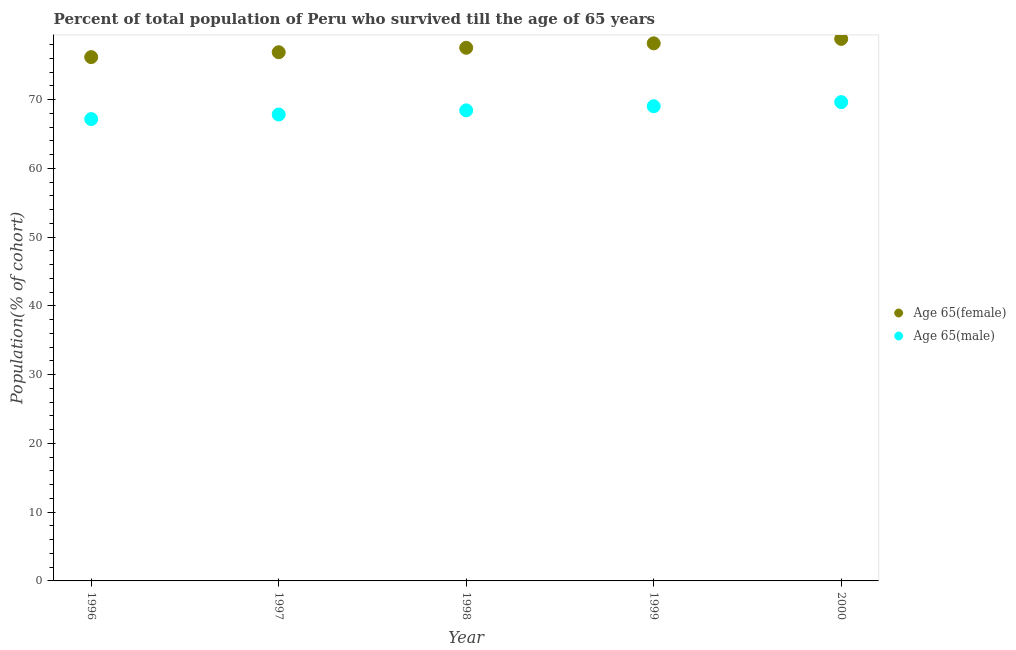How many different coloured dotlines are there?
Offer a very short reply. 2. What is the percentage of male population who survived till age of 65 in 1998?
Your answer should be very brief. 68.43. Across all years, what is the maximum percentage of male population who survived till age of 65?
Ensure brevity in your answer.  69.63. Across all years, what is the minimum percentage of female population who survived till age of 65?
Keep it short and to the point. 76.17. In which year was the percentage of male population who survived till age of 65 maximum?
Offer a very short reply. 2000. What is the total percentage of male population who survived till age of 65 in the graph?
Keep it short and to the point. 342.07. What is the difference between the percentage of male population who survived till age of 65 in 1999 and that in 2000?
Keep it short and to the point. -0.6. What is the difference between the percentage of male population who survived till age of 65 in 2000 and the percentage of female population who survived till age of 65 in 1996?
Your answer should be very brief. -6.55. What is the average percentage of female population who survived till age of 65 per year?
Offer a terse response. 77.52. In the year 1997, what is the difference between the percentage of female population who survived till age of 65 and percentage of male population who survived till age of 65?
Ensure brevity in your answer.  9.06. In how many years, is the percentage of male population who survived till age of 65 greater than 2 %?
Make the answer very short. 5. What is the ratio of the percentage of female population who survived till age of 65 in 1999 to that in 2000?
Give a very brief answer. 0.99. Is the difference between the percentage of female population who survived till age of 65 in 1999 and 2000 greater than the difference between the percentage of male population who survived till age of 65 in 1999 and 2000?
Ensure brevity in your answer.  No. What is the difference between the highest and the second highest percentage of male population who survived till age of 65?
Offer a very short reply. 0.6. What is the difference between the highest and the lowest percentage of male population who survived till age of 65?
Make the answer very short. 2.47. Is the sum of the percentage of female population who survived till age of 65 in 1996 and 1999 greater than the maximum percentage of male population who survived till age of 65 across all years?
Your answer should be compact. Yes. Is the percentage of male population who survived till age of 65 strictly less than the percentage of female population who survived till age of 65 over the years?
Your answer should be very brief. Yes. How many dotlines are there?
Your answer should be compact. 2. How many years are there in the graph?
Offer a very short reply. 5. What is the difference between two consecutive major ticks on the Y-axis?
Keep it short and to the point. 10. Does the graph contain grids?
Provide a short and direct response. No. How many legend labels are there?
Provide a succinct answer. 2. What is the title of the graph?
Your response must be concise. Percent of total population of Peru who survived till the age of 65 years. What is the label or title of the Y-axis?
Keep it short and to the point. Population(% of cohort). What is the Population(% of cohort) of Age 65(female) in 1996?
Your answer should be compact. 76.17. What is the Population(% of cohort) of Age 65(male) in 1996?
Make the answer very short. 67.16. What is the Population(% of cohort) in Age 65(female) in 1997?
Provide a short and direct response. 76.88. What is the Population(% of cohort) in Age 65(male) in 1997?
Offer a terse response. 67.83. What is the Population(% of cohort) of Age 65(female) in 1998?
Provide a succinct answer. 77.53. What is the Population(% of cohort) in Age 65(male) in 1998?
Your answer should be very brief. 68.43. What is the Population(% of cohort) of Age 65(female) in 1999?
Provide a succinct answer. 78.18. What is the Population(% of cohort) of Age 65(male) in 1999?
Your response must be concise. 69.03. What is the Population(% of cohort) in Age 65(female) in 2000?
Your answer should be compact. 78.82. What is the Population(% of cohort) of Age 65(male) in 2000?
Make the answer very short. 69.63. Across all years, what is the maximum Population(% of cohort) in Age 65(female)?
Provide a short and direct response. 78.82. Across all years, what is the maximum Population(% of cohort) of Age 65(male)?
Your answer should be compact. 69.63. Across all years, what is the minimum Population(% of cohort) in Age 65(female)?
Offer a terse response. 76.17. Across all years, what is the minimum Population(% of cohort) in Age 65(male)?
Ensure brevity in your answer.  67.16. What is the total Population(% of cohort) in Age 65(female) in the graph?
Give a very brief answer. 387.59. What is the total Population(% of cohort) of Age 65(male) in the graph?
Provide a short and direct response. 342.07. What is the difference between the Population(% of cohort) of Age 65(female) in 1996 and that in 1997?
Your answer should be compact. -0.71. What is the difference between the Population(% of cohort) of Age 65(male) in 1996 and that in 1997?
Keep it short and to the point. -0.67. What is the difference between the Population(% of cohort) of Age 65(female) in 1996 and that in 1998?
Give a very brief answer. -1.36. What is the difference between the Population(% of cohort) in Age 65(male) in 1996 and that in 1998?
Provide a short and direct response. -1.27. What is the difference between the Population(% of cohort) of Age 65(female) in 1996 and that in 1999?
Ensure brevity in your answer.  -2. What is the difference between the Population(% of cohort) of Age 65(male) in 1996 and that in 1999?
Provide a succinct answer. -1.87. What is the difference between the Population(% of cohort) in Age 65(female) in 1996 and that in 2000?
Offer a very short reply. -2.65. What is the difference between the Population(% of cohort) in Age 65(male) in 1996 and that in 2000?
Provide a succinct answer. -2.47. What is the difference between the Population(% of cohort) in Age 65(female) in 1997 and that in 1998?
Offer a terse response. -0.65. What is the difference between the Population(% of cohort) in Age 65(male) in 1997 and that in 1998?
Give a very brief answer. -0.6. What is the difference between the Population(% of cohort) of Age 65(female) in 1997 and that in 1999?
Provide a succinct answer. -1.29. What is the difference between the Population(% of cohort) in Age 65(male) in 1997 and that in 1999?
Your answer should be very brief. -1.2. What is the difference between the Population(% of cohort) in Age 65(female) in 1997 and that in 2000?
Give a very brief answer. -1.94. What is the difference between the Population(% of cohort) in Age 65(male) in 1997 and that in 2000?
Your answer should be very brief. -1.8. What is the difference between the Population(% of cohort) of Age 65(female) in 1998 and that in 1999?
Your response must be concise. -0.65. What is the difference between the Population(% of cohort) of Age 65(male) in 1998 and that in 1999?
Offer a very short reply. -0.6. What is the difference between the Population(% of cohort) in Age 65(female) in 1998 and that in 2000?
Your answer should be very brief. -1.29. What is the difference between the Population(% of cohort) of Age 65(male) in 1998 and that in 2000?
Offer a terse response. -1.2. What is the difference between the Population(% of cohort) in Age 65(female) in 1999 and that in 2000?
Provide a succinct answer. -0.65. What is the difference between the Population(% of cohort) of Age 65(male) in 1999 and that in 2000?
Keep it short and to the point. -0.6. What is the difference between the Population(% of cohort) of Age 65(female) in 1996 and the Population(% of cohort) of Age 65(male) in 1997?
Your answer should be very brief. 8.35. What is the difference between the Population(% of cohort) of Age 65(female) in 1996 and the Population(% of cohort) of Age 65(male) in 1998?
Your answer should be compact. 7.75. What is the difference between the Population(% of cohort) of Age 65(female) in 1996 and the Population(% of cohort) of Age 65(male) in 1999?
Make the answer very short. 7.15. What is the difference between the Population(% of cohort) in Age 65(female) in 1996 and the Population(% of cohort) in Age 65(male) in 2000?
Ensure brevity in your answer.  6.55. What is the difference between the Population(% of cohort) of Age 65(female) in 1997 and the Population(% of cohort) of Age 65(male) in 1998?
Make the answer very short. 8.46. What is the difference between the Population(% of cohort) of Age 65(female) in 1997 and the Population(% of cohort) of Age 65(male) in 1999?
Your response must be concise. 7.86. What is the difference between the Population(% of cohort) in Age 65(female) in 1997 and the Population(% of cohort) in Age 65(male) in 2000?
Keep it short and to the point. 7.26. What is the difference between the Population(% of cohort) of Age 65(female) in 1998 and the Population(% of cohort) of Age 65(male) in 1999?
Your answer should be compact. 8.5. What is the difference between the Population(% of cohort) in Age 65(female) in 1998 and the Population(% of cohort) in Age 65(male) in 2000?
Your response must be concise. 7.9. What is the difference between the Population(% of cohort) of Age 65(female) in 1999 and the Population(% of cohort) of Age 65(male) in 2000?
Make the answer very short. 8.55. What is the average Population(% of cohort) of Age 65(female) per year?
Offer a very short reply. 77.52. What is the average Population(% of cohort) of Age 65(male) per year?
Keep it short and to the point. 68.41. In the year 1996, what is the difference between the Population(% of cohort) of Age 65(female) and Population(% of cohort) of Age 65(male)?
Make the answer very short. 9.01. In the year 1997, what is the difference between the Population(% of cohort) of Age 65(female) and Population(% of cohort) of Age 65(male)?
Provide a short and direct response. 9.06. In the year 1998, what is the difference between the Population(% of cohort) in Age 65(female) and Population(% of cohort) in Age 65(male)?
Give a very brief answer. 9.1. In the year 1999, what is the difference between the Population(% of cohort) in Age 65(female) and Population(% of cohort) in Age 65(male)?
Your answer should be compact. 9.15. In the year 2000, what is the difference between the Population(% of cohort) of Age 65(female) and Population(% of cohort) of Age 65(male)?
Your answer should be compact. 9.2. What is the ratio of the Population(% of cohort) in Age 65(female) in 1996 to that in 1997?
Ensure brevity in your answer.  0.99. What is the ratio of the Population(% of cohort) of Age 65(male) in 1996 to that in 1997?
Provide a short and direct response. 0.99. What is the ratio of the Population(% of cohort) in Age 65(female) in 1996 to that in 1998?
Give a very brief answer. 0.98. What is the ratio of the Population(% of cohort) in Age 65(male) in 1996 to that in 1998?
Offer a terse response. 0.98. What is the ratio of the Population(% of cohort) in Age 65(female) in 1996 to that in 1999?
Give a very brief answer. 0.97. What is the ratio of the Population(% of cohort) of Age 65(male) in 1996 to that in 1999?
Provide a succinct answer. 0.97. What is the ratio of the Population(% of cohort) of Age 65(female) in 1996 to that in 2000?
Keep it short and to the point. 0.97. What is the ratio of the Population(% of cohort) of Age 65(male) in 1996 to that in 2000?
Ensure brevity in your answer.  0.96. What is the ratio of the Population(% of cohort) in Age 65(female) in 1997 to that in 1998?
Keep it short and to the point. 0.99. What is the ratio of the Population(% of cohort) in Age 65(male) in 1997 to that in 1998?
Ensure brevity in your answer.  0.99. What is the ratio of the Population(% of cohort) in Age 65(female) in 1997 to that in 1999?
Provide a short and direct response. 0.98. What is the ratio of the Population(% of cohort) in Age 65(male) in 1997 to that in 1999?
Your answer should be very brief. 0.98. What is the ratio of the Population(% of cohort) of Age 65(female) in 1997 to that in 2000?
Ensure brevity in your answer.  0.98. What is the ratio of the Population(% of cohort) in Age 65(male) in 1997 to that in 2000?
Your answer should be very brief. 0.97. What is the ratio of the Population(% of cohort) of Age 65(male) in 1998 to that in 1999?
Offer a terse response. 0.99. What is the ratio of the Population(% of cohort) of Age 65(female) in 1998 to that in 2000?
Ensure brevity in your answer.  0.98. What is the ratio of the Population(% of cohort) of Age 65(male) in 1998 to that in 2000?
Ensure brevity in your answer.  0.98. What is the difference between the highest and the second highest Population(% of cohort) in Age 65(female)?
Provide a succinct answer. 0.65. What is the difference between the highest and the second highest Population(% of cohort) of Age 65(male)?
Your answer should be very brief. 0.6. What is the difference between the highest and the lowest Population(% of cohort) in Age 65(female)?
Your answer should be compact. 2.65. What is the difference between the highest and the lowest Population(% of cohort) of Age 65(male)?
Provide a short and direct response. 2.47. 